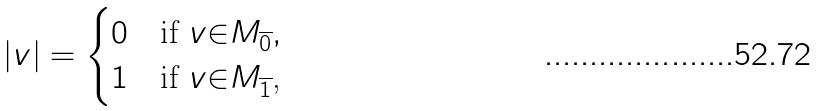Convert formula to latex. <formula><loc_0><loc_0><loc_500><loc_500>| v | = \begin{cases} 0 & \text {if $v{\in}M_{\overline{0}}$} , \\ 1 & \text {if $v{\in}M_{\overline{1}}$,} \end{cases}</formula> 